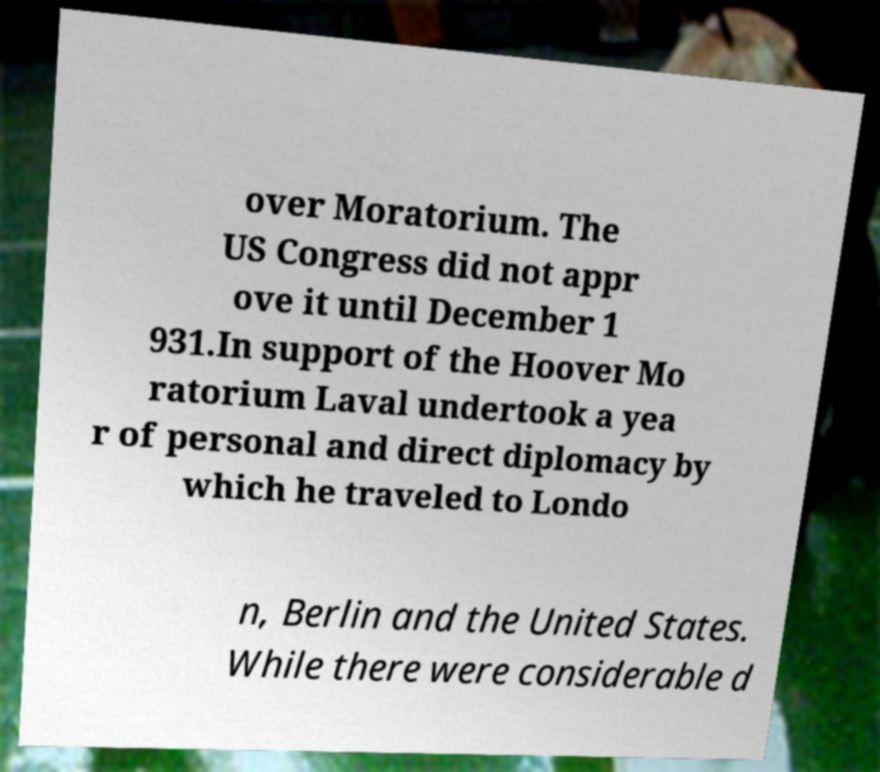Could you extract and type out the text from this image? over Moratorium. The US Congress did not appr ove it until December 1 931.In support of the Hoover Mo ratorium Laval undertook a yea r of personal and direct diplomacy by which he traveled to Londo n, Berlin and the United States. While there were considerable d 